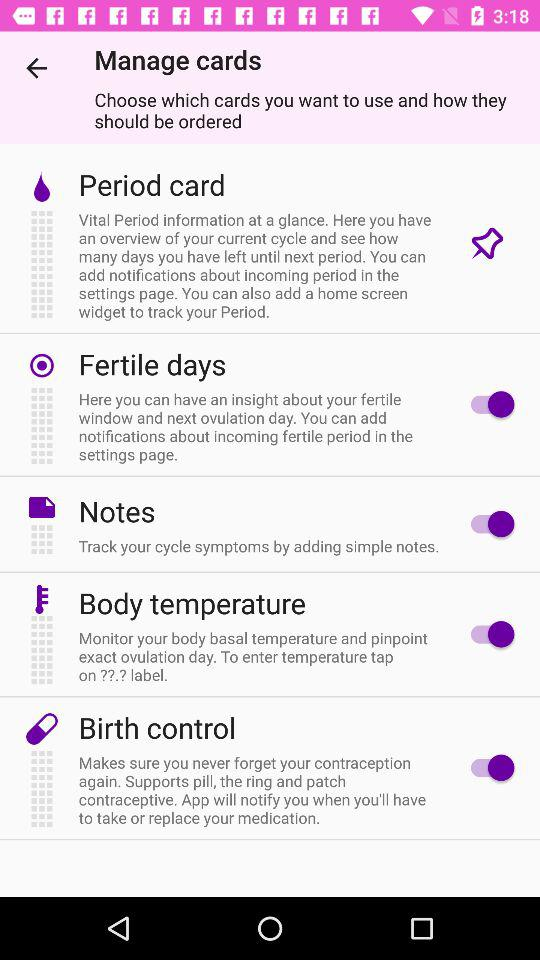What is the status of the "Fertile days"? The status is "on". 